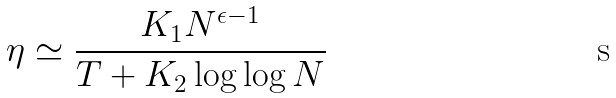Convert formula to latex. <formula><loc_0><loc_0><loc_500><loc_500>\eta \simeq \frac { K _ { 1 } N ^ { \epsilon - 1 } } { T + K _ { 2 } \log \log N }</formula> 